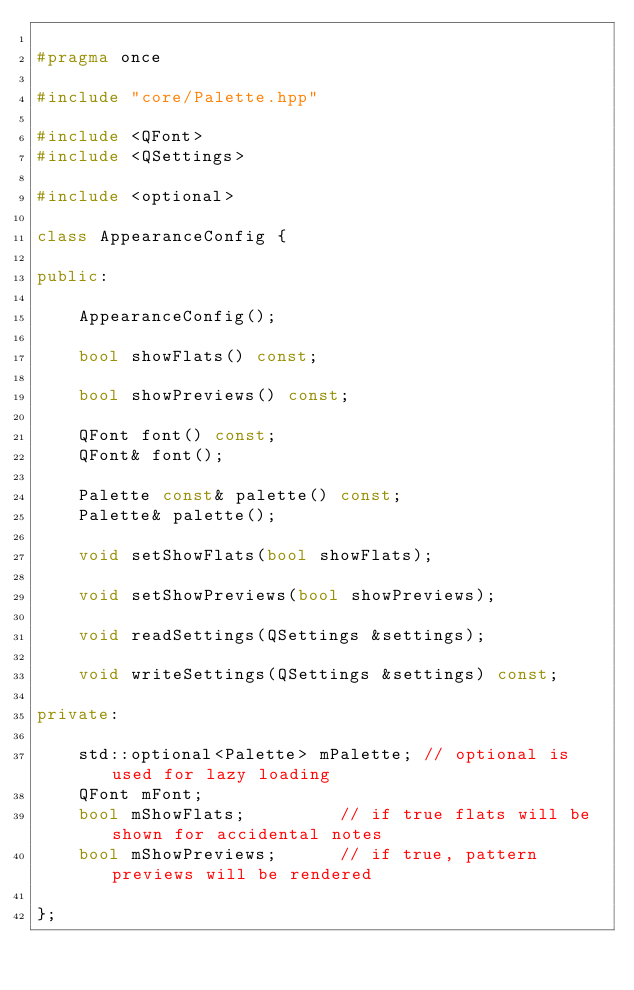Convert code to text. <code><loc_0><loc_0><loc_500><loc_500><_C++_>
#pragma once

#include "core/Palette.hpp"

#include <QFont>
#include <QSettings>

#include <optional>

class AppearanceConfig {

public:

    AppearanceConfig();

    bool showFlats() const;

    bool showPreviews() const;

    QFont font() const;
    QFont& font();

    Palette const& palette() const;
    Palette& palette();

    void setShowFlats(bool showFlats);

    void setShowPreviews(bool showPreviews);

    void readSettings(QSettings &settings);

    void writeSettings(QSettings &settings) const;

private:

    std::optional<Palette> mPalette; // optional is used for lazy loading
    QFont mFont;
    bool mShowFlats;         // if true flats will be shown for accidental notes
    bool mShowPreviews;      // if true, pattern previews will be rendered

};
</code> 